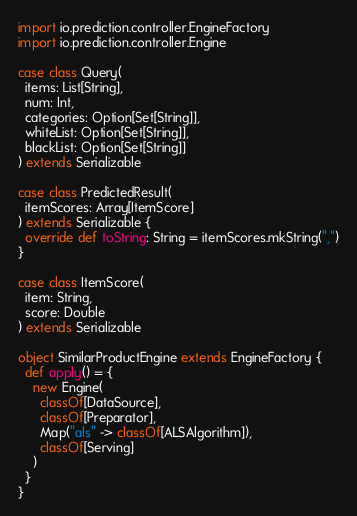<code> <loc_0><loc_0><loc_500><loc_500><_Scala_>import io.prediction.controller.EngineFactory
import io.prediction.controller.Engine

case class Query(
  items: List[String],
  num: Int,
  categories: Option[Set[String]],
  whiteList: Option[Set[String]],
  blackList: Option[Set[String]]
) extends Serializable

case class PredictedResult(
  itemScores: Array[ItemScore]
) extends Serializable {
  override def toString: String = itemScores.mkString(",")
}

case class ItemScore(
  item: String,
  score: Double
) extends Serializable

object SimilarProductEngine extends EngineFactory {
  def apply() = {
    new Engine(
      classOf[DataSource],
      classOf[Preparator],
      Map("als" -> classOf[ALSAlgorithm]),
      classOf[Serving]
    )
  }
}
</code> 